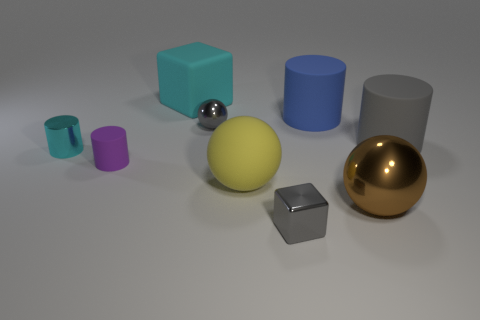Subtract all matte cylinders. How many cylinders are left? 1 Subtract all spheres. How many objects are left? 6 Subtract all cyan blocks. Subtract all big cylinders. How many objects are left? 6 Add 8 small gray metal spheres. How many small gray metal spheres are left? 9 Add 1 large red metal cylinders. How many large red metal cylinders exist? 1 Subtract all cyan cubes. How many cubes are left? 1 Subtract 0 blue cubes. How many objects are left? 9 Subtract 3 spheres. How many spheres are left? 0 Subtract all blue cubes. Subtract all cyan cylinders. How many cubes are left? 2 Subtract all cyan cylinders. How many purple balls are left? 0 